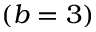Convert formula to latex. <formula><loc_0><loc_0><loc_500><loc_500>( b = 3 )</formula> 